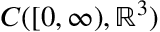Convert formula to latex. <formula><loc_0><loc_0><loc_500><loc_500>C ( [ 0 , \infty ) , \mathbb { R } ^ { 3 } )</formula> 